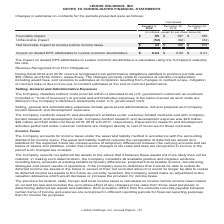According to Leidos Holdings's financial document, What was the Unfavorable impact in 2018? According to the financial document, (62) (in millions). The relevant text states: "le impact $ 95 $ 167 $ 185 Unfavorable impact (52) (62) (82) Net favorable impact to income before income taxes $ 43 $ 105 $ 103..." Also, What was the Favorable impact in 2020, 2018 and 2017 respectively? The document contains multiple relevant values: $95, $167, $185 (in millions). From the document: "except for per share amounts) Favorable impact $ 95 $ 167 $ 185 Unfavorable impact (52) (62) (82) Net favorable impact to income before income taxes $..." Also, What was the Unfavorable impact in 2020? According to the financial document, (52) (in millions). The relevant text states: "vorable impact $ 95 $ 167 $ 185 Unfavorable impact (52) (62) (82) Net favorable impact to income before income taxes $ 43 $ 105 $ 103..." Additionally, In which period was Favorable impact more than 100 million? The document shows two values: 2018 and 2017. Locate and analyze favorable impact in row 5. From the document: "January 3, 2020 December 28, 2018 December 29, 2017 January 3, 2020 December 28, 2018 December 29, 2017..." Also, can you calculate: What is the average Unfavorable impact in 2018 and 2017? To answer this question, I need to perform calculations using the financial data. The calculation is: -(62 + 82) / 2, which equals -72 (in millions). This is based on the information: "impact $ 95 $ 167 $ 185 Unfavorable impact (52) (62) (82) Net favorable impact to income before income taxes $ 43 $ 105 $ 103 ct $ 95 $ 167 $ 185 Unfavorable impact (52) (62) (82) Net favorable impact..." The key data points involved are: 62, 82. Also, can you calculate: What is the change in the Net favorable impact to income before income taxes from 2018 to 2017? Based on the calculation: 105 - 103, the result is 2 (in millions). This is based on the information: "impact to income before income taxes $ 43 $ 105 $ 103 rable impact to income before income taxes $ 43 $ 105 $ 103..." The key data points involved are: 103, 105. 